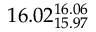Convert formula to latex. <formula><loc_0><loc_0><loc_500><loc_500>1 6 . 0 2 _ { 1 5 . 9 7 } ^ { 1 6 . 0 6 }</formula> 